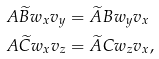<formula> <loc_0><loc_0><loc_500><loc_500>A \widetilde { B } w _ { x } v _ { y } & = \widetilde { A } B w _ { y } v _ { x } \\ A \widetilde { C } w _ { x } v _ { z } & = \widetilde { A } C w _ { z } v _ { x } ,</formula> 